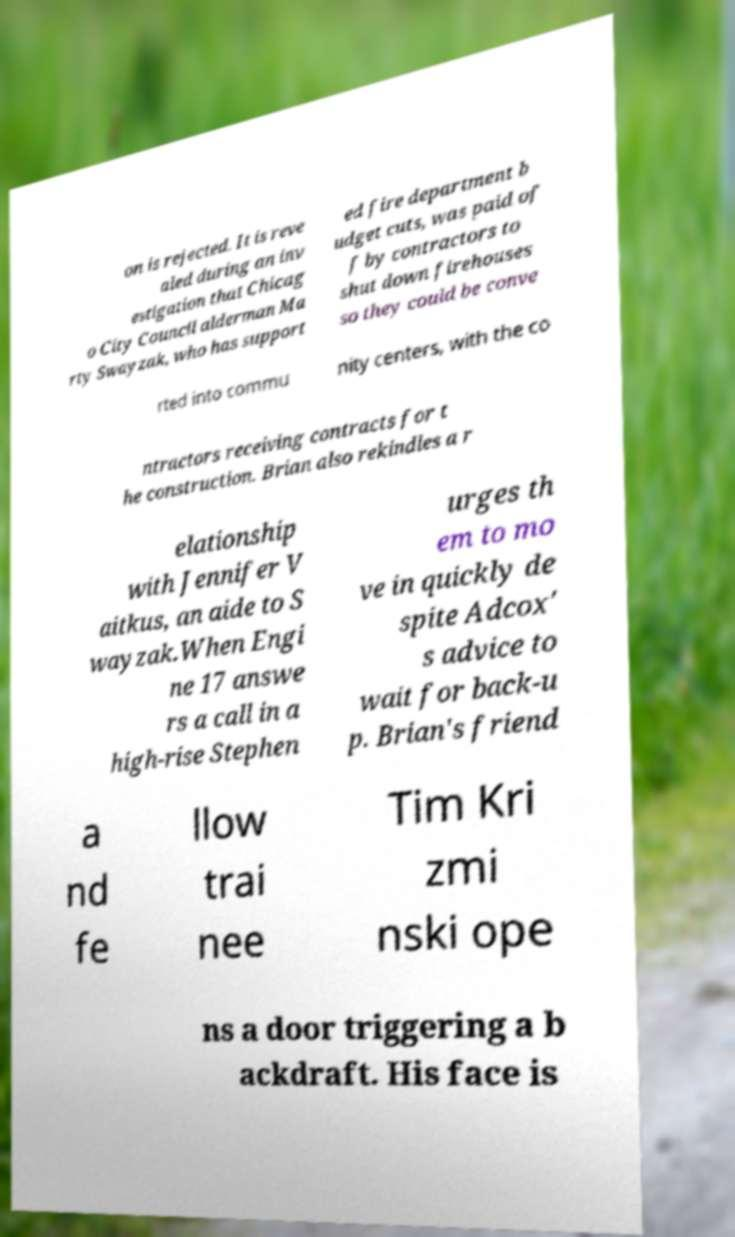Please identify and transcribe the text found in this image. on is rejected. It is reve aled during an inv estigation that Chicag o City Council alderman Ma rty Swayzak, who has support ed fire department b udget cuts, was paid of f by contractors to shut down firehouses so they could be conve rted into commu nity centers, with the co ntractors receiving contracts for t he construction. Brian also rekindles a r elationship with Jennifer V aitkus, an aide to S wayzak.When Engi ne 17 answe rs a call in a high-rise Stephen urges th em to mo ve in quickly de spite Adcox' s advice to wait for back-u p. Brian's friend a nd fe llow trai nee Tim Kri zmi nski ope ns a door triggering a b ackdraft. His face is 